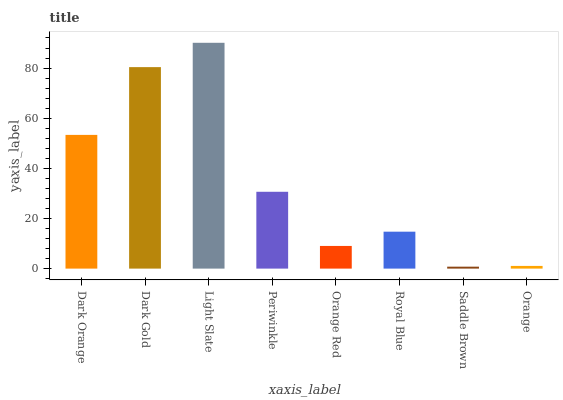Is Saddle Brown the minimum?
Answer yes or no. Yes. Is Light Slate the maximum?
Answer yes or no. Yes. Is Dark Gold the minimum?
Answer yes or no. No. Is Dark Gold the maximum?
Answer yes or no. No. Is Dark Gold greater than Dark Orange?
Answer yes or no. Yes. Is Dark Orange less than Dark Gold?
Answer yes or no. Yes. Is Dark Orange greater than Dark Gold?
Answer yes or no. No. Is Dark Gold less than Dark Orange?
Answer yes or no. No. Is Periwinkle the high median?
Answer yes or no. Yes. Is Royal Blue the low median?
Answer yes or no. Yes. Is Dark Orange the high median?
Answer yes or no. No. Is Saddle Brown the low median?
Answer yes or no. No. 